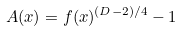<formula> <loc_0><loc_0><loc_500><loc_500>A ( x ) = f ( x ) ^ { ( D - 2 ) / 4 } - 1</formula> 